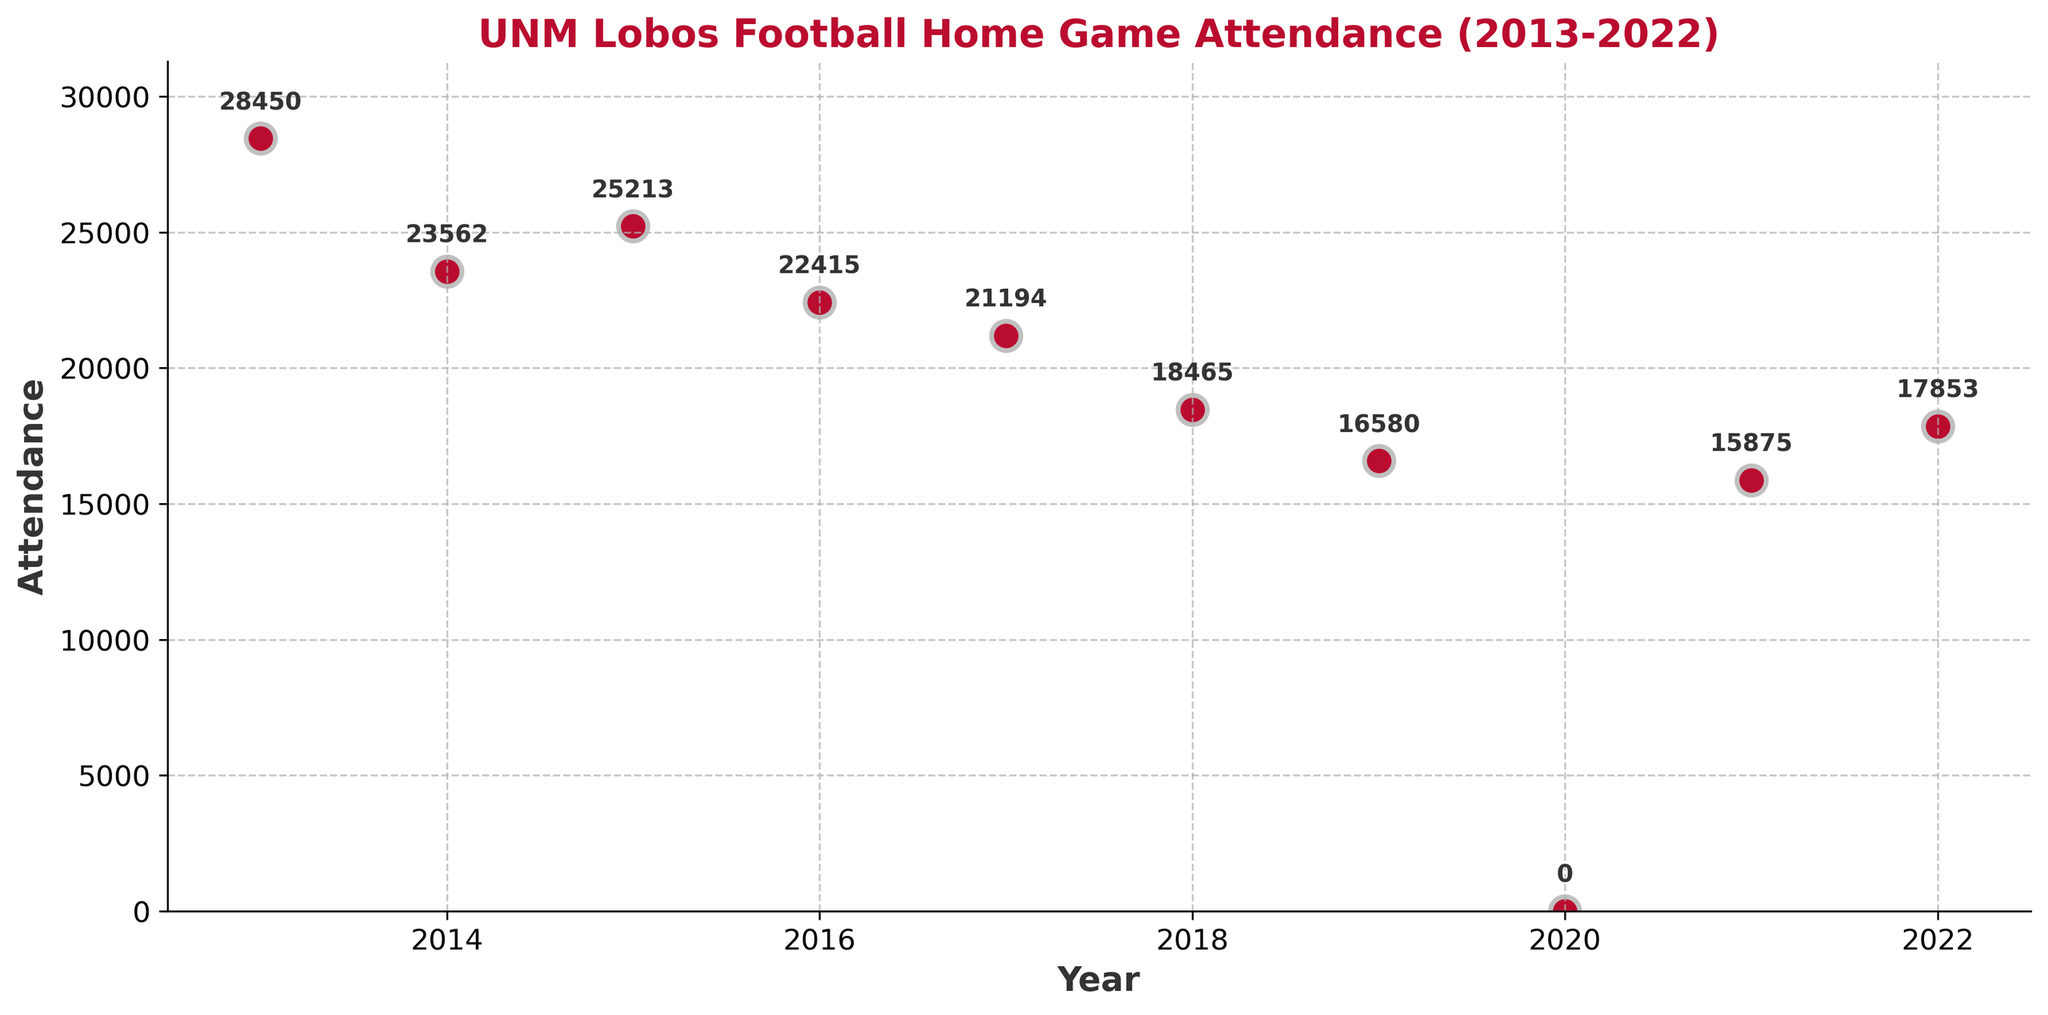What is the attendance figure for UNM home games in 2013? Find the 2013 data point on the plot, and note the y-value (attendance) associated with it.
Answer: 28450 How many years had an attendance greater than 20,000? Count the number of data points that are located above the 20,000 attendance mark on the y-axis.
Answer: Five What was the attendance in 2020, and why is it significant? Locate the year 2020 on the x-axis and note the value. The attendance is notable because it stands out compared to other years.
Answer: 0, significant due to the pandemic What’s the average attendance from 2013 to 2022, excluding 2020? Sum the attendance values for all years except 2020, then divide by the number of those years (9). (28450 + 23562 + 25213 + 22415 + 21194 + 18465 + 16580 + 15875 + 17853) / 9
Answer: 21040.78 Which year had the highest game attendance, and what was the figure? Identify the data point with the highest y-value (attendance) and note its corresponding year.
Answer: 2013, 28450 Compare the attendance in 2015 and 2016. Which year had higher attendance and by how much? Locate the data points for 2015 and 2016, then subtract the attendance of 2016 from 2015.
Answer: 2015 had higher attendance by 1798 Was the attendance trend generally increasing or decreasing over the decade? Observe the overall slope/trend of the data points from 2013 to 2022.
Answer: Decreasing By how much did the attendance change from 2014 to 2015? Subtract the attendance in 2014 from the attendance in 2015.
Answer: 1651 What is the median attendance value over the given period, excluding 2020? List the attendance values for all years except 2020, sort them, and find the middle value. (15875, 16580, 17853, 18465, 21194, 22415, 23562, 25213, 28450)
Answer: 21194 What was the lowest attendance recorded, and in which year? Identify the data point with the lowest y-value (attendance), excluding 2020, and note its corresponding year.
Answer: 2021, 15875 